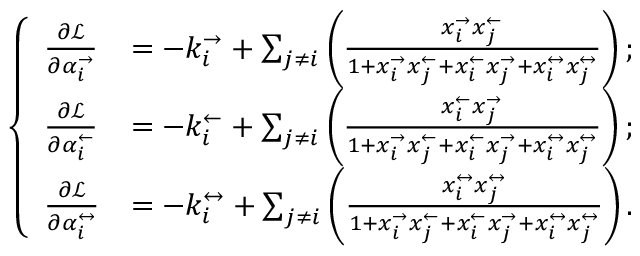Convert formula to latex. <formula><loc_0><loc_0><loc_500><loc_500>\left \{ \begin{array} { l l } { \frac { \partial \mathcal { L } } { \partial \alpha _ { i } ^ { \rightarrow } } } & { = - k _ { i } ^ { \rightarrow } + \sum _ { j \neq i } \left ( \frac { x _ { i } ^ { \rightarrow } x _ { j } ^ { \leftarrow } } { 1 + x _ { i } ^ { \rightarrow } x _ { j } ^ { \leftarrow } + x _ { i } ^ { \leftarrow } x _ { j } ^ { \rightarrow } + x _ { i } ^ { \leftrightarrow } x _ { j } ^ { \leftrightarrow } } \right ) ; } \\ { \frac { \partial \mathcal { L } } { \partial \alpha _ { i } ^ { \leftarrow } } } & { = - k _ { i } ^ { \leftarrow } + \sum _ { j \neq i } \left ( \frac { x _ { i } ^ { \leftarrow } x _ { j } ^ { \rightarrow } } { 1 + x _ { i } ^ { \rightarrow } x _ { j } ^ { \leftarrow } + x _ { i } ^ { \leftarrow } x _ { j } ^ { \rightarrow } + x _ { i } ^ { \leftrightarrow } x _ { j } ^ { \leftrightarrow } } \right ) ; } \\ { \frac { \partial \mathcal { L } } { \partial \alpha _ { i } ^ { \leftrightarrow } } } & { = - k _ { i } ^ { \leftrightarrow } + \sum _ { j \neq i } \left ( \frac { x _ { i } ^ { \leftrightarrow } x _ { j } ^ { \leftrightarrow } } { 1 + x _ { i } ^ { \rightarrow } x _ { j } ^ { \leftarrow } + x _ { i } ^ { \leftarrow } x _ { j } ^ { \rightarrow } + x _ { i } ^ { \leftrightarrow } x _ { j } ^ { \leftrightarrow } } \right ) . } \end{array}</formula> 